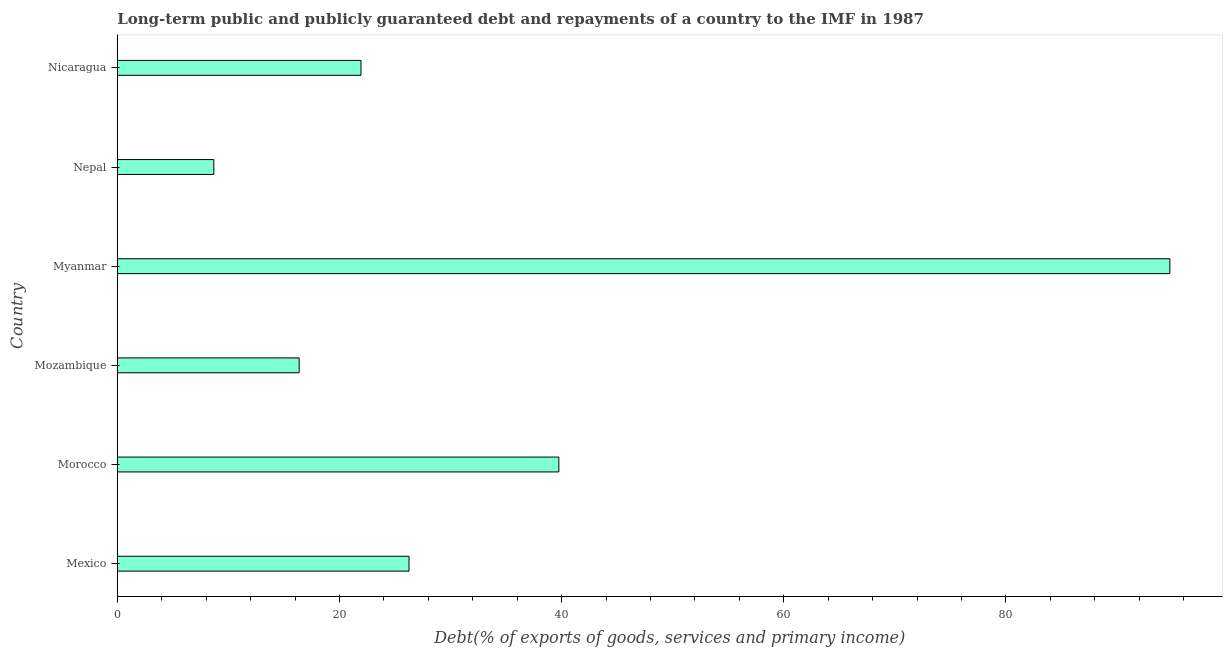What is the title of the graph?
Give a very brief answer. Long-term public and publicly guaranteed debt and repayments of a country to the IMF in 1987. What is the label or title of the X-axis?
Your response must be concise. Debt(% of exports of goods, services and primary income). What is the label or title of the Y-axis?
Keep it short and to the point. Country. What is the debt service in Morocco?
Offer a very short reply. 39.75. Across all countries, what is the maximum debt service?
Ensure brevity in your answer.  94.77. Across all countries, what is the minimum debt service?
Offer a very short reply. 8.69. In which country was the debt service maximum?
Make the answer very short. Myanmar. In which country was the debt service minimum?
Provide a short and direct response. Nepal. What is the sum of the debt service?
Ensure brevity in your answer.  207.79. What is the difference between the debt service in Mexico and Mozambique?
Your answer should be very brief. 9.89. What is the average debt service per country?
Offer a terse response. 34.63. What is the median debt service?
Make the answer very short. 24.1. What is the ratio of the debt service in Mexico to that in Nepal?
Offer a very short reply. 3.02. Is the difference between the debt service in Mexico and Nepal greater than the difference between any two countries?
Give a very brief answer. No. What is the difference between the highest and the second highest debt service?
Your answer should be compact. 55.01. What is the difference between the highest and the lowest debt service?
Keep it short and to the point. 86.08. How many countries are there in the graph?
Make the answer very short. 6. What is the Debt(% of exports of goods, services and primary income) of Mexico?
Your response must be concise. 26.27. What is the Debt(% of exports of goods, services and primary income) in Morocco?
Your answer should be compact. 39.75. What is the Debt(% of exports of goods, services and primary income) of Mozambique?
Your response must be concise. 16.37. What is the Debt(% of exports of goods, services and primary income) of Myanmar?
Offer a very short reply. 94.77. What is the Debt(% of exports of goods, services and primary income) in Nepal?
Offer a very short reply. 8.69. What is the Debt(% of exports of goods, services and primary income) in Nicaragua?
Your answer should be very brief. 21.94. What is the difference between the Debt(% of exports of goods, services and primary income) in Mexico and Morocco?
Ensure brevity in your answer.  -13.49. What is the difference between the Debt(% of exports of goods, services and primary income) in Mexico and Mozambique?
Provide a succinct answer. 9.89. What is the difference between the Debt(% of exports of goods, services and primary income) in Mexico and Myanmar?
Keep it short and to the point. -68.5. What is the difference between the Debt(% of exports of goods, services and primary income) in Mexico and Nepal?
Keep it short and to the point. 17.58. What is the difference between the Debt(% of exports of goods, services and primary income) in Mexico and Nicaragua?
Make the answer very short. 4.32. What is the difference between the Debt(% of exports of goods, services and primary income) in Morocco and Mozambique?
Make the answer very short. 23.38. What is the difference between the Debt(% of exports of goods, services and primary income) in Morocco and Myanmar?
Provide a succinct answer. -55.01. What is the difference between the Debt(% of exports of goods, services and primary income) in Morocco and Nepal?
Your answer should be very brief. 31.06. What is the difference between the Debt(% of exports of goods, services and primary income) in Morocco and Nicaragua?
Your response must be concise. 17.81. What is the difference between the Debt(% of exports of goods, services and primary income) in Mozambique and Myanmar?
Offer a terse response. -78.39. What is the difference between the Debt(% of exports of goods, services and primary income) in Mozambique and Nepal?
Make the answer very short. 7.68. What is the difference between the Debt(% of exports of goods, services and primary income) in Mozambique and Nicaragua?
Offer a terse response. -5.57. What is the difference between the Debt(% of exports of goods, services and primary income) in Myanmar and Nepal?
Provide a succinct answer. 86.08. What is the difference between the Debt(% of exports of goods, services and primary income) in Myanmar and Nicaragua?
Ensure brevity in your answer.  72.82. What is the difference between the Debt(% of exports of goods, services and primary income) in Nepal and Nicaragua?
Provide a short and direct response. -13.25. What is the ratio of the Debt(% of exports of goods, services and primary income) in Mexico to that in Morocco?
Your answer should be compact. 0.66. What is the ratio of the Debt(% of exports of goods, services and primary income) in Mexico to that in Mozambique?
Your response must be concise. 1.6. What is the ratio of the Debt(% of exports of goods, services and primary income) in Mexico to that in Myanmar?
Offer a very short reply. 0.28. What is the ratio of the Debt(% of exports of goods, services and primary income) in Mexico to that in Nepal?
Make the answer very short. 3.02. What is the ratio of the Debt(% of exports of goods, services and primary income) in Mexico to that in Nicaragua?
Your response must be concise. 1.2. What is the ratio of the Debt(% of exports of goods, services and primary income) in Morocco to that in Mozambique?
Offer a terse response. 2.43. What is the ratio of the Debt(% of exports of goods, services and primary income) in Morocco to that in Myanmar?
Keep it short and to the point. 0.42. What is the ratio of the Debt(% of exports of goods, services and primary income) in Morocco to that in Nepal?
Make the answer very short. 4.57. What is the ratio of the Debt(% of exports of goods, services and primary income) in Morocco to that in Nicaragua?
Your answer should be compact. 1.81. What is the ratio of the Debt(% of exports of goods, services and primary income) in Mozambique to that in Myanmar?
Your response must be concise. 0.17. What is the ratio of the Debt(% of exports of goods, services and primary income) in Mozambique to that in Nepal?
Your answer should be very brief. 1.88. What is the ratio of the Debt(% of exports of goods, services and primary income) in Mozambique to that in Nicaragua?
Offer a very short reply. 0.75. What is the ratio of the Debt(% of exports of goods, services and primary income) in Myanmar to that in Nepal?
Ensure brevity in your answer.  10.9. What is the ratio of the Debt(% of exports of goods, services and primary income) in Myanmar to that in Nicaragua?
Your response must be concise. 4.32. What is the ratio of the Debt(% of exports of goods, services and primary income) in Nepal to that in Nicaragua?
Provide a short and direct response. 0.4. 